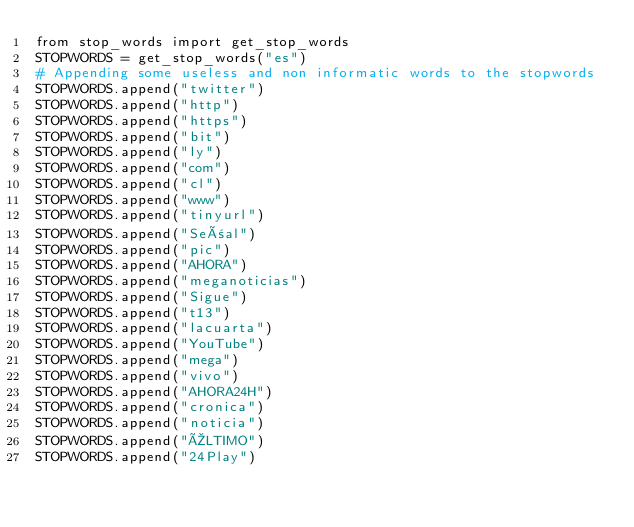<code> <loc_0><loc_0><loc_500><loc_500><_Python_>from stop_words import get_stop_words
STOPWORDS = get_stop_words("es")
# Appending some useless and non informatic words to the stopwords
STOPWORDS.append("twitter")
STOPWORDS.append("http")
STOPWORDS.append("https")
STOPWORDS.append("bit")
STOPWORDS.append("ly")
STOPWORDS.append("com")
STOPWORDS.append("cl")
STOPWORDS.append("www")
STOPWORDS.append("tinyurl")
STOPWORDS.append("Señal")
STOPWORDS.append("pic")
STOPWORDS.append("AHORA")
STOPWORDS.append("meganoticias")
STOPWORDS.append("Sigue")
STOPWORDS.append("t13")
STOPWORDS.append("lacuarta")
STOPWORDS.append("YouTube")
STOPWORDS.append("mega")
STOPWORDS.append("vivo")
STOPWORDS.append("AHORA24H")
STOPWORDS.append("cronica")
STOPWORDS.append("noticia")
STOPWORDS.append("ÚLTIMO")
STOPWORDS.append("24Play")
</code> 